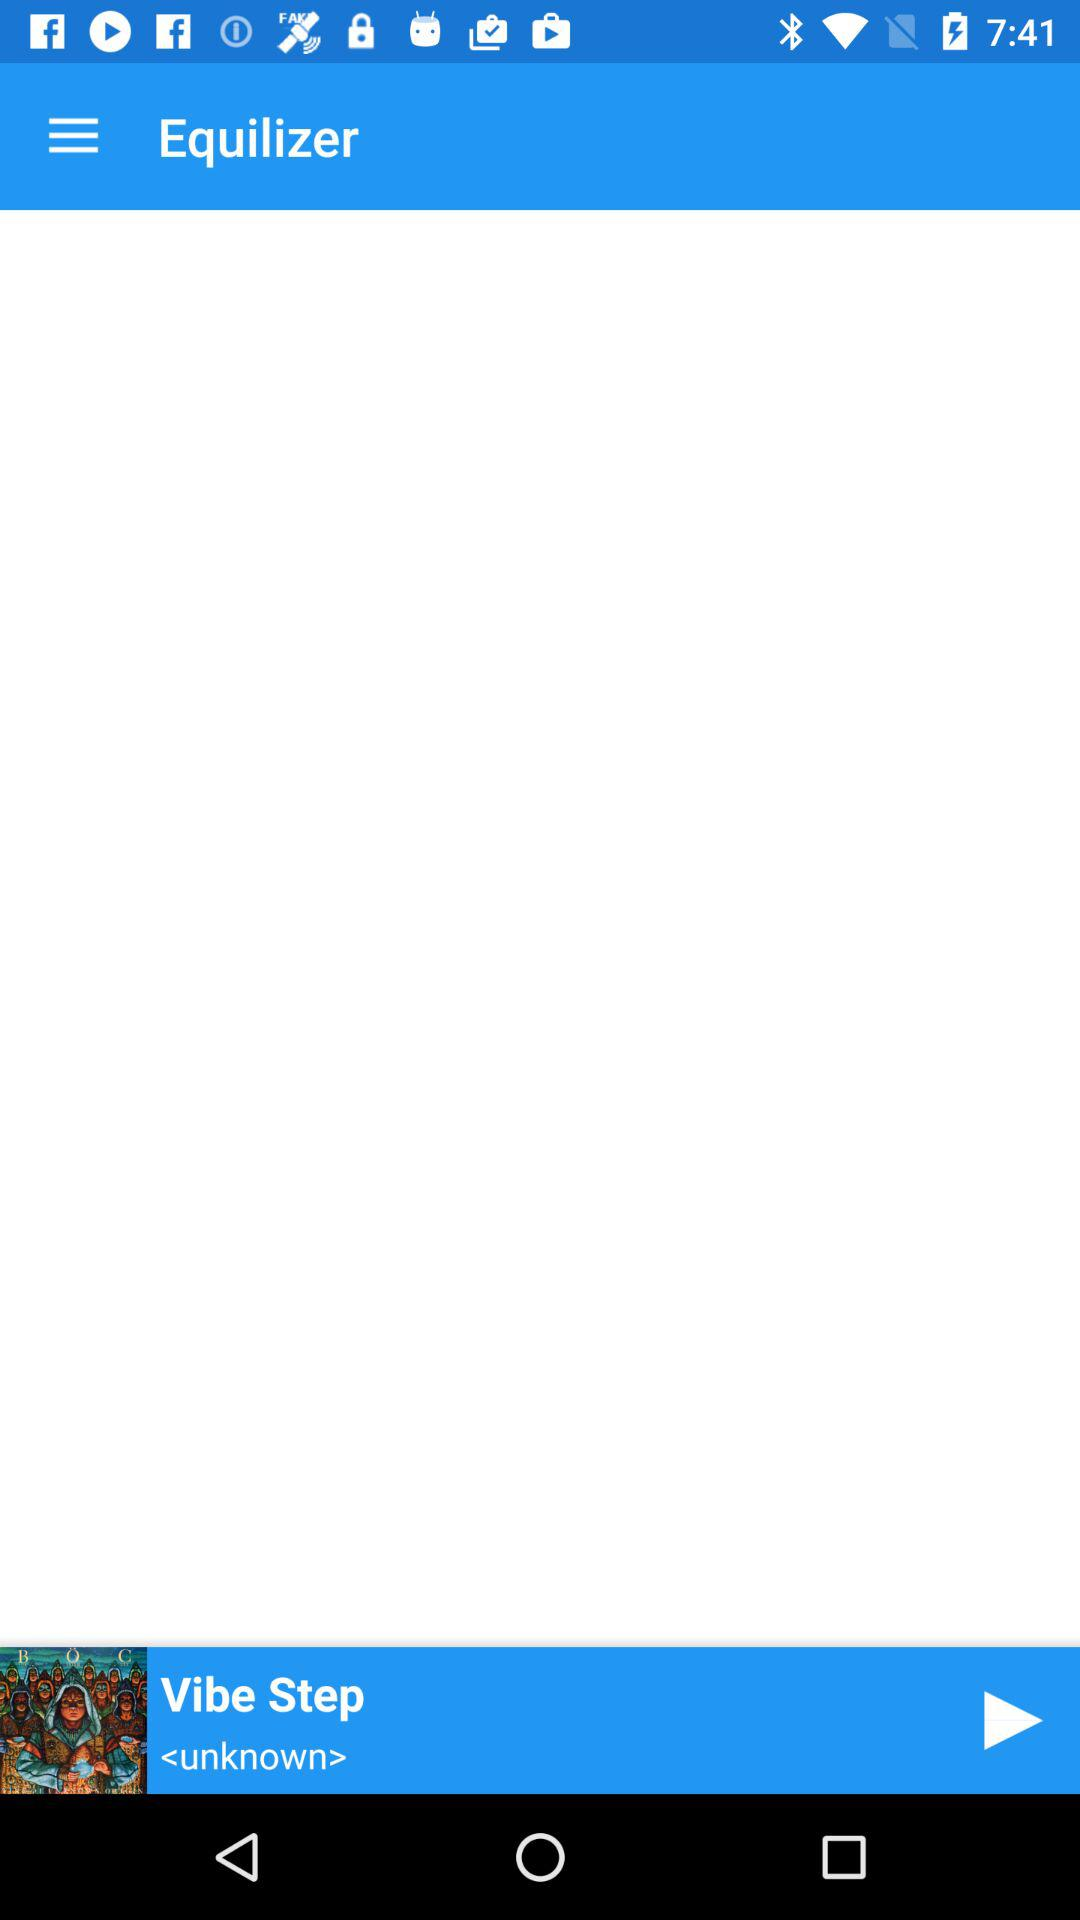What song is playing? The playing song is "Vibe Step". 